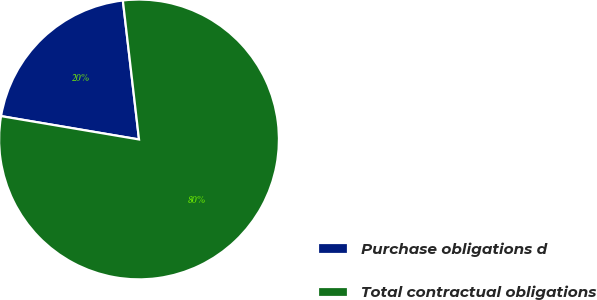<chart> <loc_0><loc_0><loc_500><loc_500><pie_chart><fcel>Purchase obligations d<fcel>Total contractual obligations<nl><fcel>20.49%<fcel>79.51%<nl></chart> 